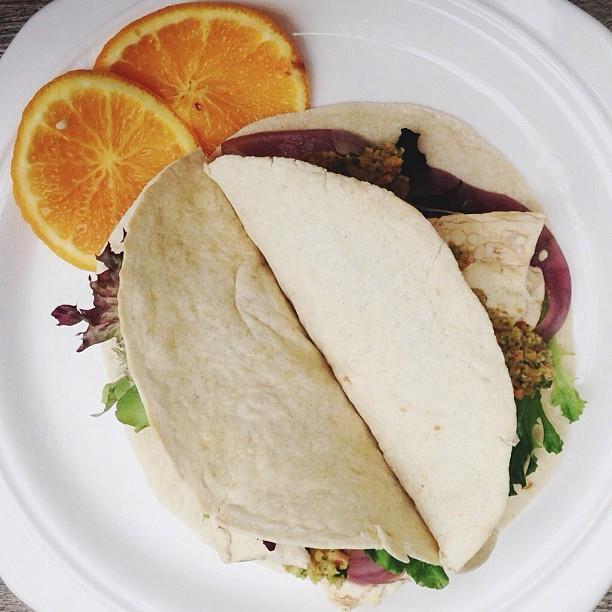How many oranges can be seen?
Give a very brief answer. 2. How many sandwiches can you see?
Give a very brief answer. 2. How many trains are there on the tracks?
Give a very brief answer. 0. 